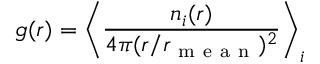Convert formula to latex. <formula><loc_0><loc_0><loc_500><loc_500>g ( r ) = \left \langle \frac { n _ { i } ( r ) } { 4 \pi ( r / r _ { m e a n } ) ^ { 2 } } \right \rangle _ { i }</formula> 